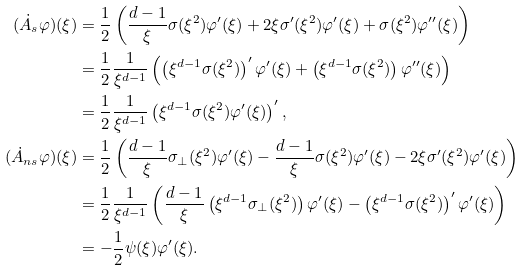Convert formula to latex. <formula><loc_0><loc_0><loc_500><loc_500>( \dot { A } _ { s } \varphi ) ( \xi ) & = \frac { 1 } { 2 } \left ( \frac { d - 1 } { \xi } \sigma ( \xi ^ { 2 } ) \varphi ^ { \prime } ( \xi ) + 2 \xi \sigma ^ { \prime } ( \xi ^ { 2 } ) \varphi ^ { \prime } ( \xi ) + \sigma ( \xi ^ { 2 } ) \varphi ^ { \prime \prime } ( \xi ) \right ) \\ & = \frac { 1 } { 2 } \frac { 1 } { \xi ^ { d - 1 } } \left ( \left ( \xi ^ { d - 1 } \sigma ( \xi ^ { 2 } ) \right ) ^ { \prime } \varphi ^ { \prime } ( \xi ) + \left ( \xi ^ { d - 1 } \sigma ( \xi ^ { 2 } ) \right ) \varphi ^ { \prime \prime } ( \xi ) \right ) \\ & = \frac { 1 } { 2 } \frac { 1 } { \xi ^ { d - 1 } } \left ( \xi ^ { d - 1 } \sigma ( \xi ^ { 2 } ) \varphi ^ { \prime } ( \xi ) \right ) ^ { \prime } , \\ ( \dot { A } _ { n s } \varphi ) ( \xi ) & = \frac { 1 } { 2 } \left ( \frac { d - 1 } { \xi } \sigma _ { \perp } ( \xi ^ { 2 } ) \varphi ^ { \prime } ( \xi ) - \frac { d - 1 } { \xi } \sigma ( \xi ^ { 2 } ) \varphi ^ { \prime } ( \xi ) - 2 \xi \sigma ^ { \prime } ( \xi ^ { 2 } ) \varphi ^ { \prime } ( \xi ) \right ) \\ & = \frac { 1 } { 2 } \frac { 1 } { \xi ^ { d - 1 } } \left ( \frac { d - 1 } { \xi } \left ( \xi ^ { d - 1 } \sigma _ { \perp } ( \xi ^ { 2 } ) \right ) \varphi ^ { \prime } ( \xi ) - \left ( \xi ^ { d - 1 } \sigma ( \xi ^ { 2 } ) \right ) ^ { \prime } \varphi ^ { \prime } ( \xi ) \right ) \\ & = - \frac { 1 } { 2 } \psi ( \xi ) \varphi ^ { \prime } ( \xi ) .</formula> 